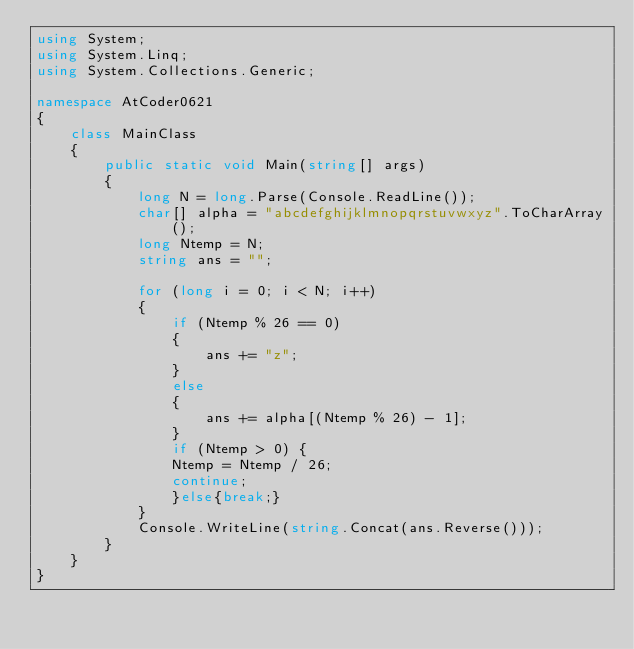Convert code to text. <code><loc_0><loc_0><loc_500><loc_500><_C#_>using System;
using System.Linq;
using System.Collections.Generic;
 
namespace AtCoder0621
{
    class MainClass
    {
        public static void Main(string[] args)
        {
            long N = long.Parse(Console.ReadLine());
            char[] alpha = "abcdefghijklmnopqrstuvwxyz".ToCharArray();
            long Ntemp = N;
            string ans = "";
         
            for (long i = 0; i < N; i++)
            {
                if (Ntemp % 26 == 0)
                {
                    ans += "z";
                }
                else
                {
                    ans += alpha[(Ntemp % 26) - 1];
                }
                if (Ntemp > 0) {
                Ntemp = Ntemp / 26;
                continue;
                }else{break;}
            }
            Console.WriteLine(string.Concat(ans.Reverse()));
        }
    }
}</code> 